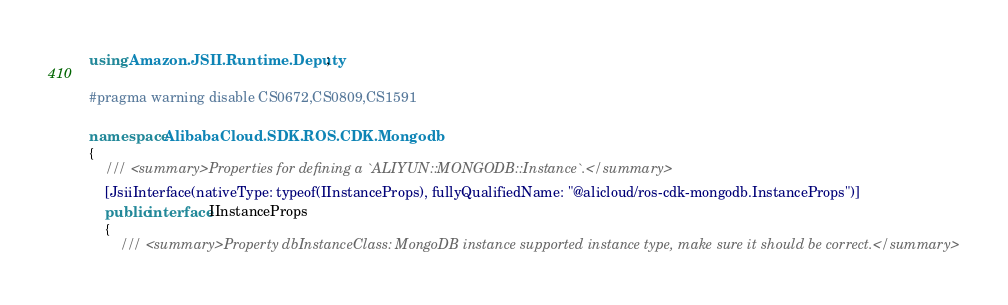Convert code to text. <code><loc_0><loc_0><loc_500><loc_500><_C#_>using Amazon.JSII.Runtime.Deputy;

#pragma warning disable CS0672,CS0809,CS1591

namespace AlibabaCloud.SDK.ROS.CDK.Mongodb
{
    /// <summary>Properties for defining a `ALIYUN::MONGODB::Instance`.</summary>
    [JsiiInterface(nativeType: typeof(IInstanceProps), fullyQualifiedName: "@alicloud/ros-cdk-mongodb.InstanceProps")]
    public interface IInstanceProps
    {
        /// <summary>Property dbInstanceClass: MongoDB instance supported instance type, make sure it should be correct.</summary></code> 